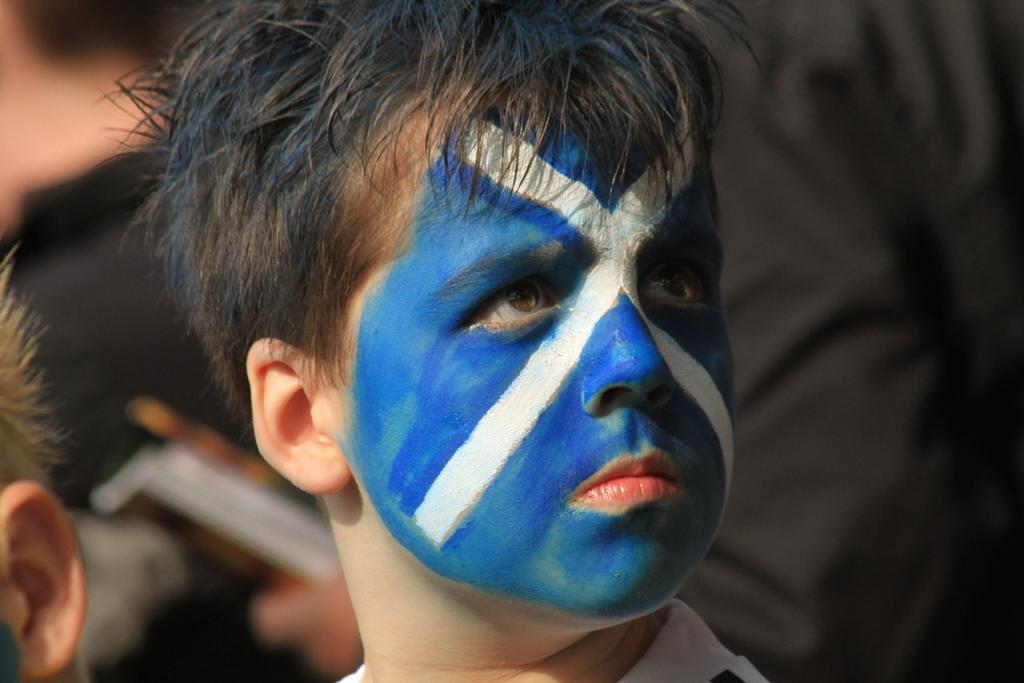What is the main subject of the picture? There is a child in the picture. How is the child's face decorated? The child's face has blue and white paint on it. Can you describe the background of the image? The background of the image is slightly blurred. Are there any other people visible in the image? Yes, there are a few more people visible in the background. What type of poison is the child holding in the image? There is no poison present in the image; the child's face has blue and white paint on it. Can you tell me how many elbows are visible in the image? The number of elbows cannot be determined from the image, as it only shows the child's face and the background. 